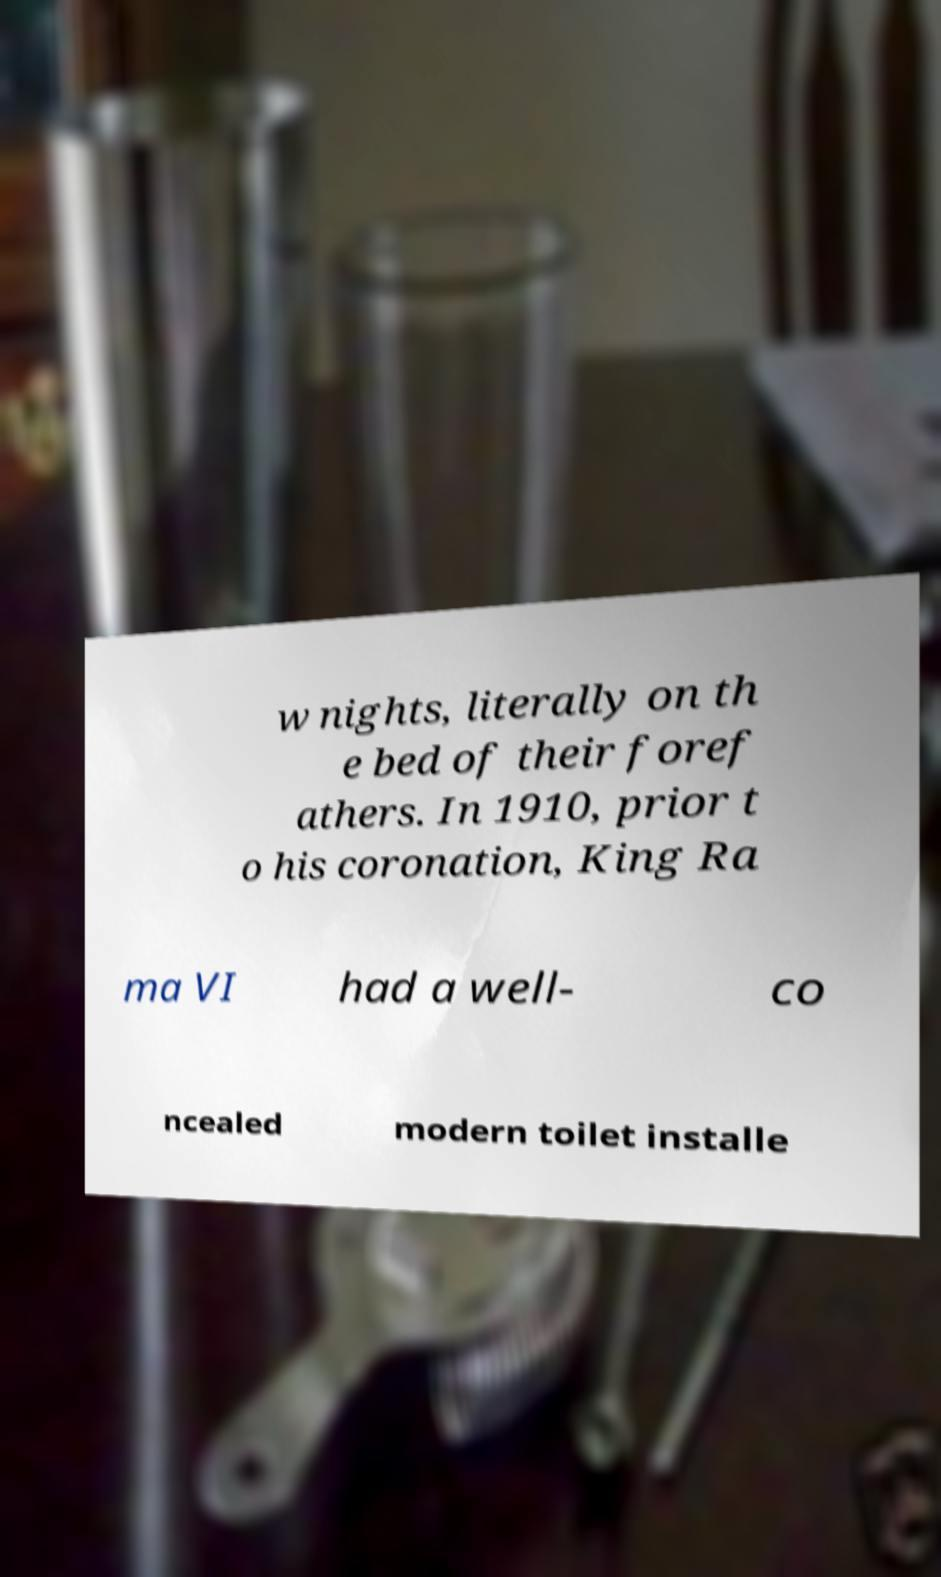What messages or text are displayed in this image? I need them in a readable, typed format. w nights, literally on th e bed of their foref athers. In 1910, prior t o his coronation, King Ra ma VI had a well- co ncealed modern toilet installe 